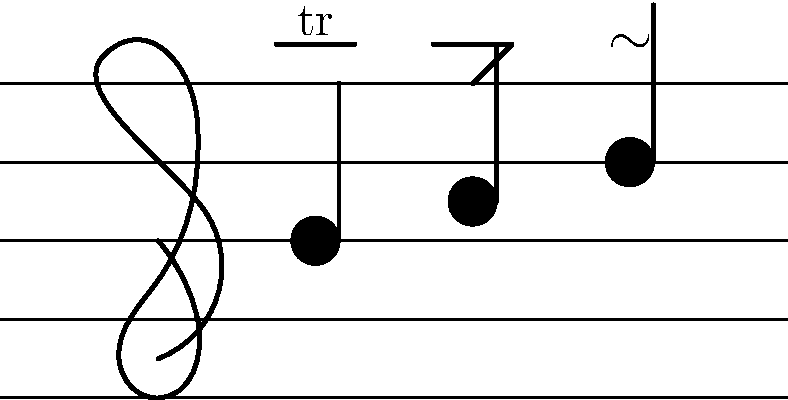Identify the three baroque musical ornaments shown in the sheet music above the notes. To identify the baroque musical ornaments in the sheet music, let's examine each symbol above the notes:

1. Above the first note:
   - We see "tr" written above a horizontal line.
   - This is the symbol for a trill, which involves rapidly alternating between the main note and the note above it.

2. Above the second note:
   - We see a symbol that looks like a sharp zigzag.
   - This represents a mordent, which involves a rapid alternation between the main note and the note below it, returning to the main note.

3. Above the third note:
   - We see a symbol that resembles a sideways "S" or a wave.
   - This is the symbol for a turn, which involves playing the note above the written note, the written note, the note below, and then returning to the written note.

These three ornaments - trill, mordent, and turn - are common in baroque music and were often used to add expression and complexity to melodic lines.
Answer: Trill, mordent, turn 